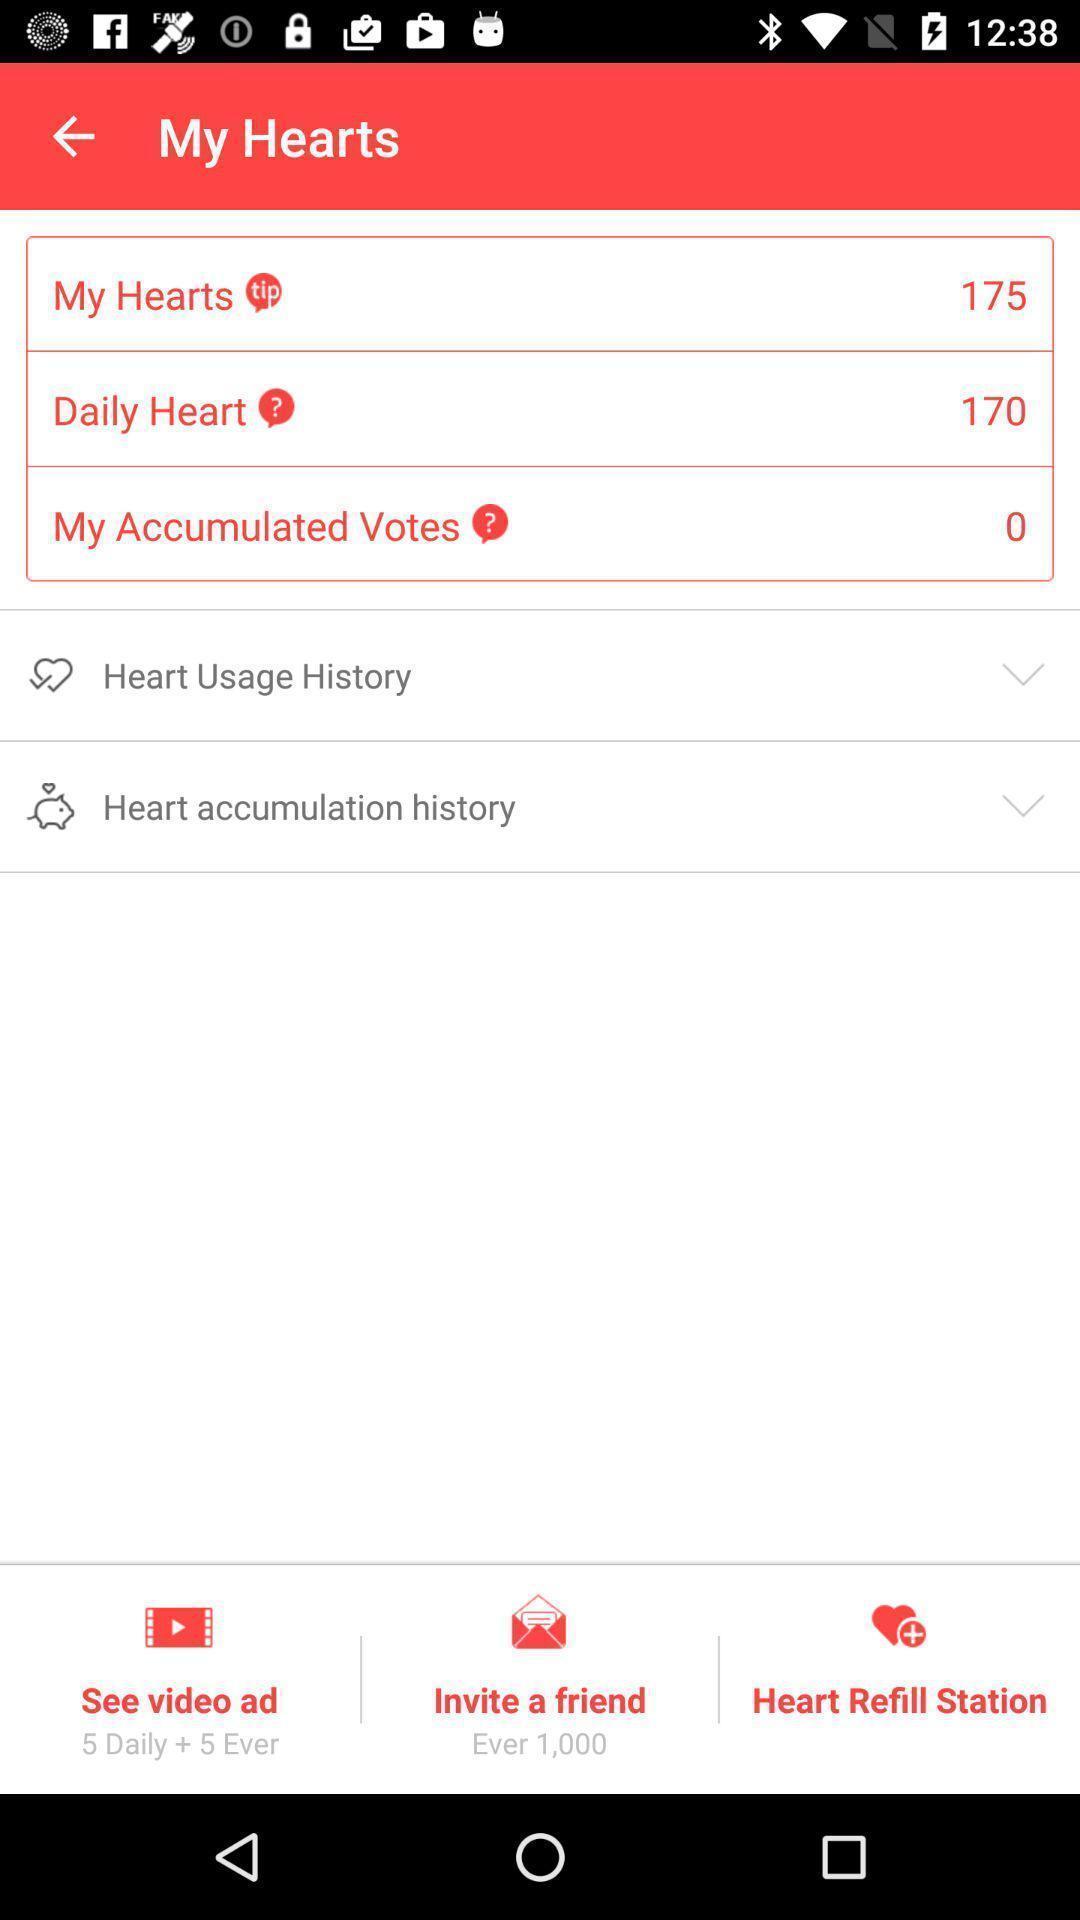Describe the content in this image. Screen shows number of options in a health app. 